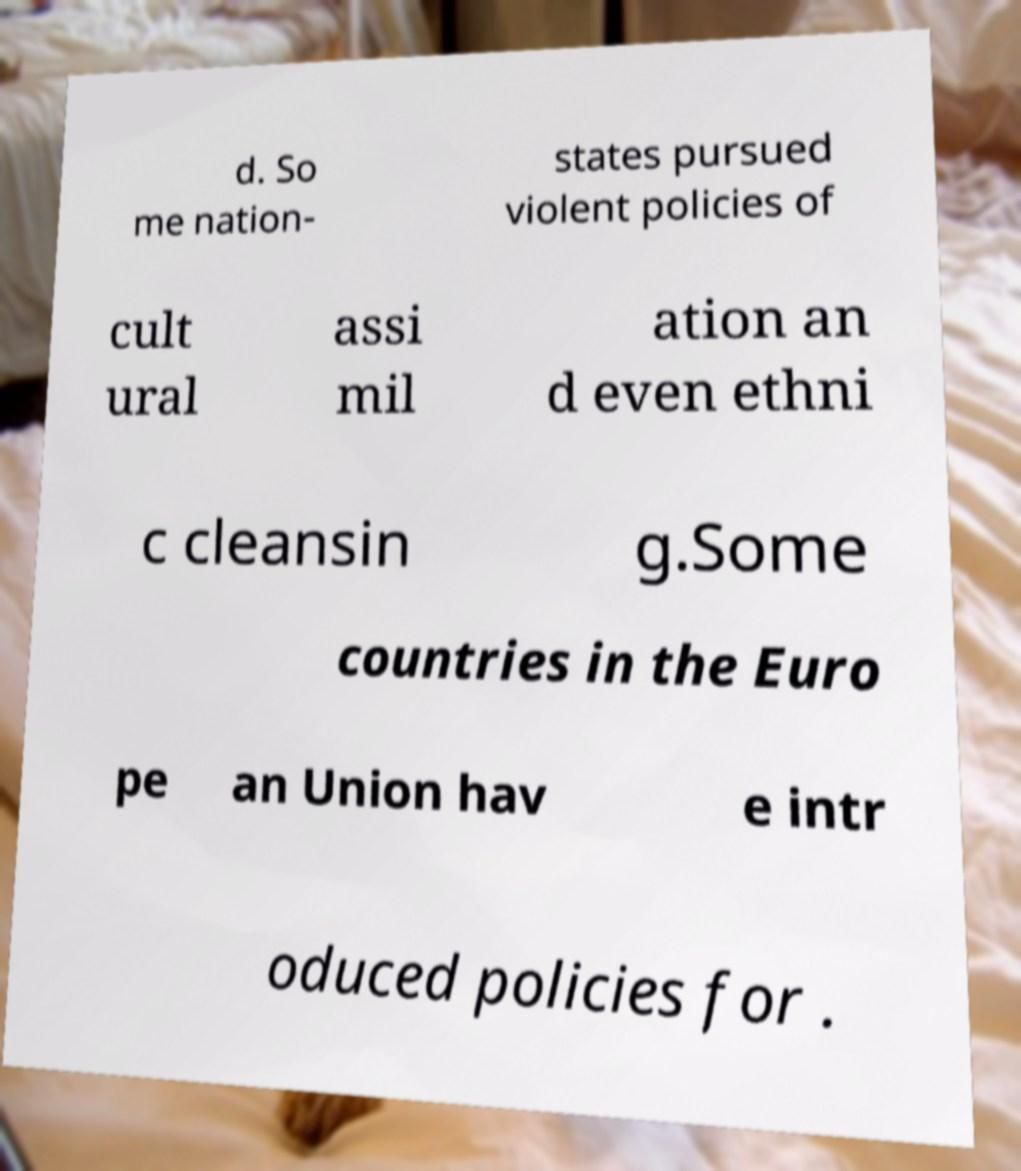Could you extract and type out the text from this image? d. So me nation- states pursued violent policies of cult ural assi mil ation an d even ethni c cleansin g.Some countries in the Euro pe an Union hav e intr oduced policies for . 